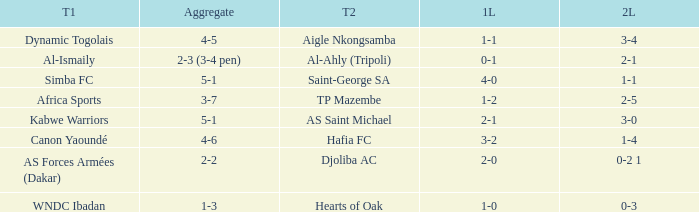When Kabwe Warriors (team 1) played, what was the result of the 1st leg? 2-1. 